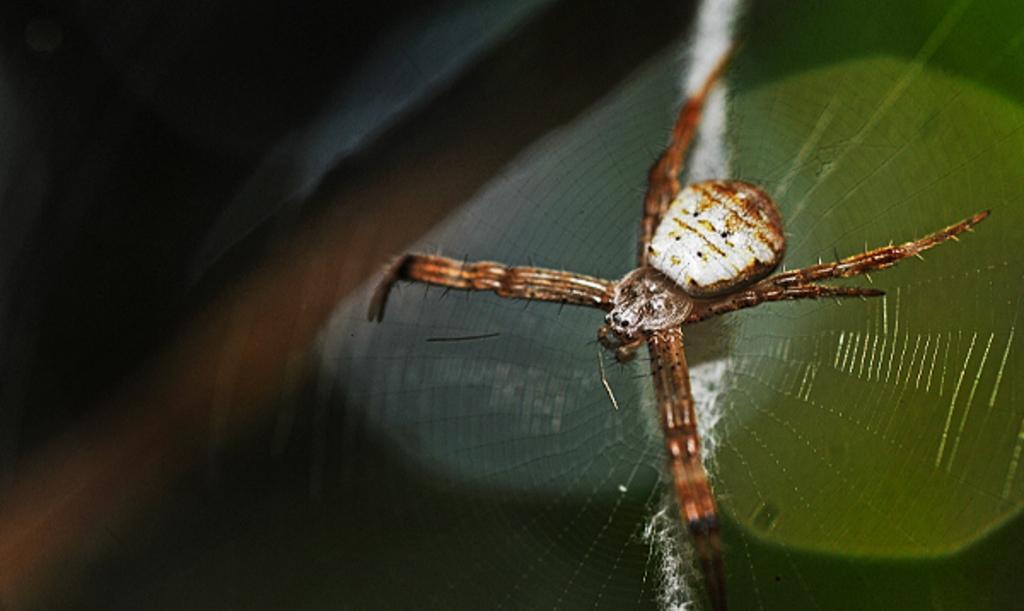Could you give a brief overview of what you see in this image? In this picture there is a brown color spider sitting on the green leaf. Behind there is a blur background. 